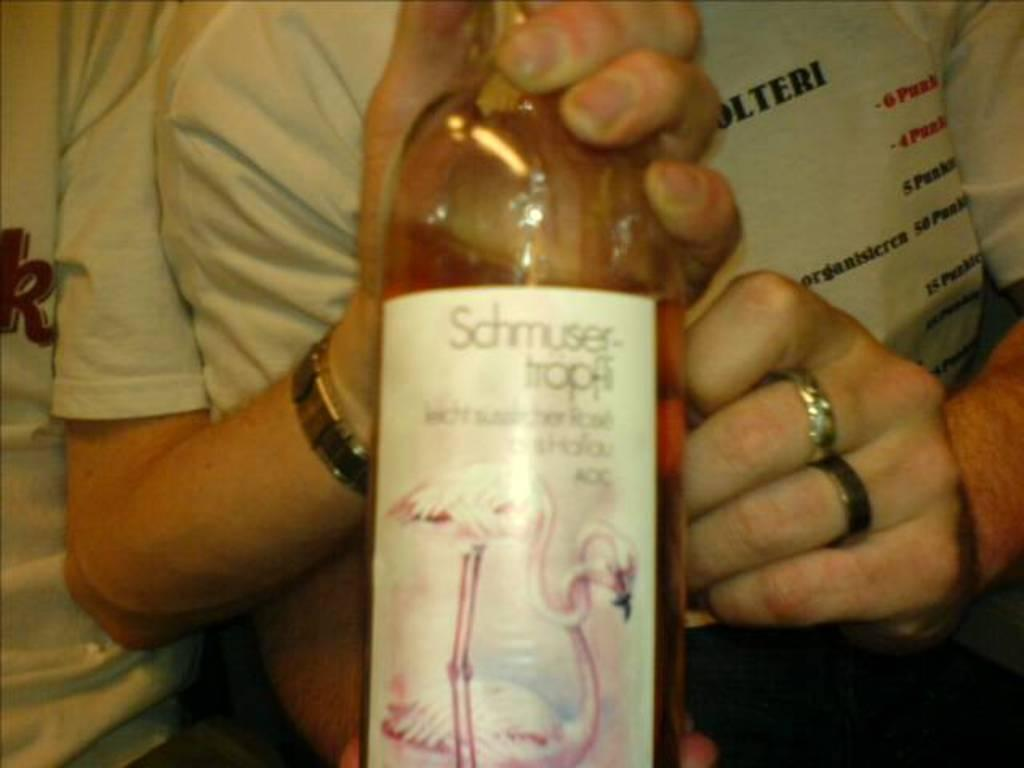<image>
Share a concise interpretation of the image provided. a new bottle of scmusertrpfi with a flamingo displayed 